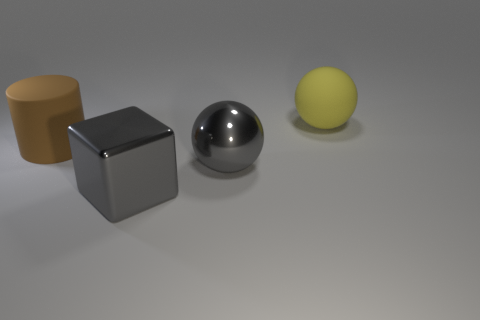Add 2 gray objects. How many objects exist? 6 Subtract all cylinders. How many objects are left? 3 Add 4 big balls. How many big balls are left? 6 Add 2 brown matte cylinders. How many brown matte cylinders exist? 3 Subtract 0 purple blocks. How many objects are left? 4 Subtract all gray matte spheres. Subtract all shiny blocks. How many objects are left? 3 